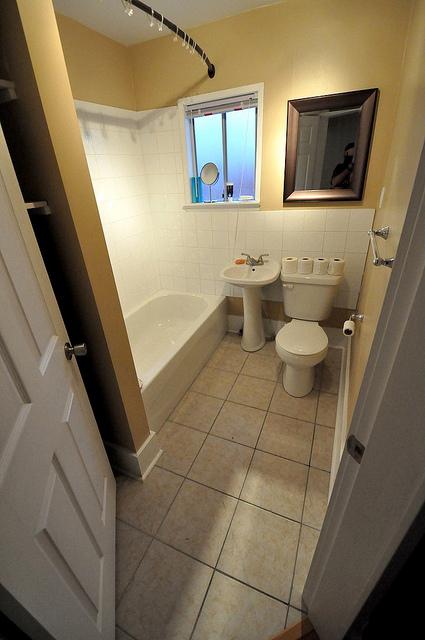Why is a shower curtain needed?
Be succinct. Yes. Is the window open or closed?
Answer briefly. Closed. What kind of soap is on the sink?
Short answer required. Bar. How many rolls of toilet paper are on top of the toilet?
Write a very short answer. 4. Are there curtains on the window?
Keep it brief. No. Does this room need remodeled?
Short answer required. No. How many tiles are in the room?
Write a very short answer. 24. 